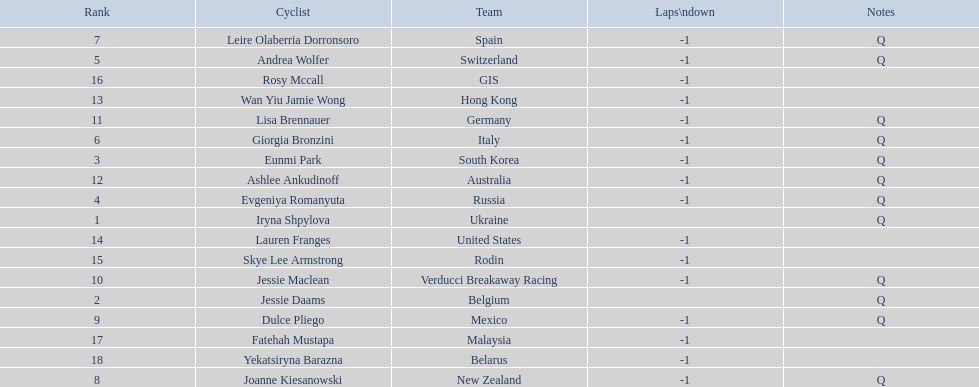Write the full table. {'header': ['Rank', 'Cyclist', 'Team', 'Laps\\ndown', 'Notes'], 'rows': [['7', 'Leire Olaberria Dorronsoro', 'Spain', '-1', 'Q'], ['5', 'Andrea Wolfer', 'Switzerland', '-1', 'Q'], ['16', 'Rosy Mccall', 'GIS', '-1', ''], ['13', 'Wan Yiu Jamie Wong', 'Hong Kong', '-1', ''], ['11', 'Lisa Brennauer', 'Germany', '-1', 'Q'], ['6', 'Giorgia Bronzini', 'Italy', '-1', 'Q'], ['3', 'Eunmi Park', 'South Korea', '-1', 'Q'], ['12', 'Ashlee Ankudinoff', 'Australia', '-1', 'Q'], ['4', 'Evgeniya Romanyuta', 'Russia', '-1', 'Q'], ['1', 'Iryna Shpylova', 'Ukraine', '', 'Q'], ['14', 'Lauren Franges', 'United States', '-1', ''], ['15', 'Skye Lee Armstrong', 'Rodin', '-1', ''], ['10', 'Jessie Maclean', 'Verducci Breakaway Racing', '-1', 'Q'], ['2', 'Jessie Daams', 'Belgium', '', 'Q'], ['9', 'Dulce Pliego', 'Mexico', '-1', 'Q'], ['17', 'Fatehah Mustapa', 'Malaysia', '-1', ''], ['18', 'Yekatsiryna Barazna', 'Belarus', '-1', ''], ['8', 'Joanne Kiesanowski', 'New Zealand', '-1', 'Q']]} How many cyclist are not listed with a country team? 3. 